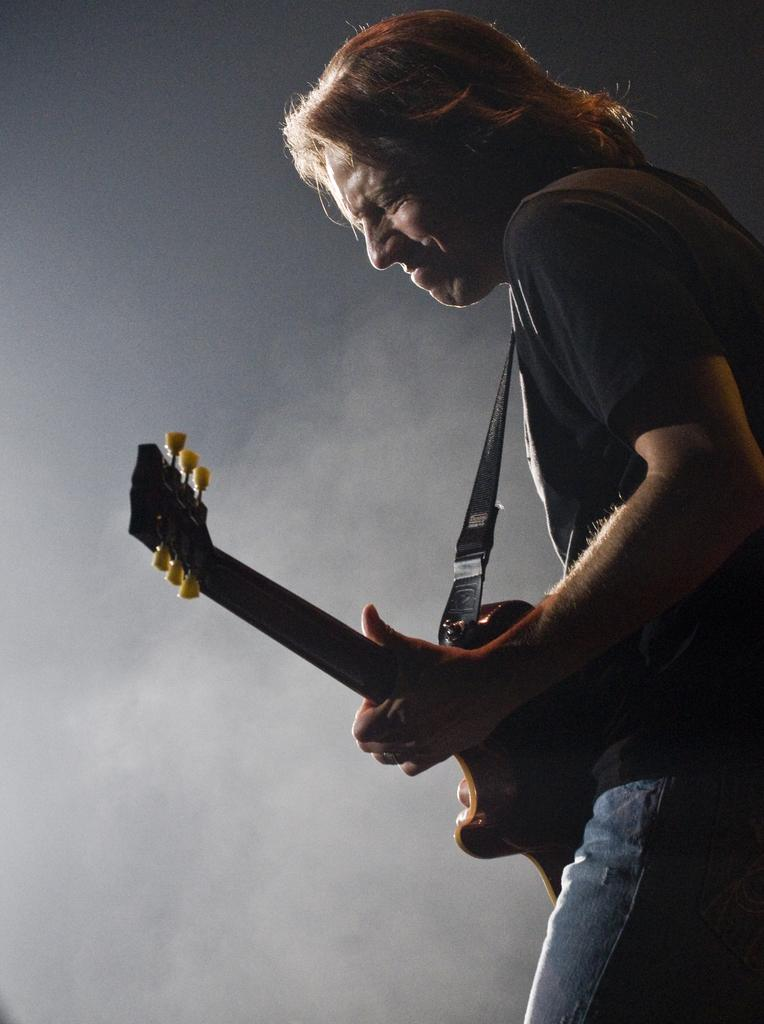What is the main subject of the image? There is a person in the image. What is the person doing in the image? The person is playing a guitar. What type of grape is the person eating while playing the guitar in the image? There is no grape present in the image, and the person is not eating anything. 